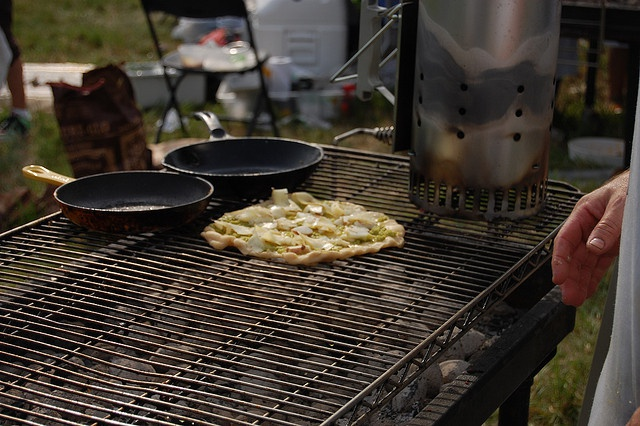Describe the objects in this image and their specific colors. I can see people in black, gray, and maroon tones, chair in black, gray, darkgray, and darkgreen tones, pizza in black, tan, and olive tones, people in black, gray, maroon, and darkgreen tones, and bowl in black, darkgray, and gray tones in this image. 